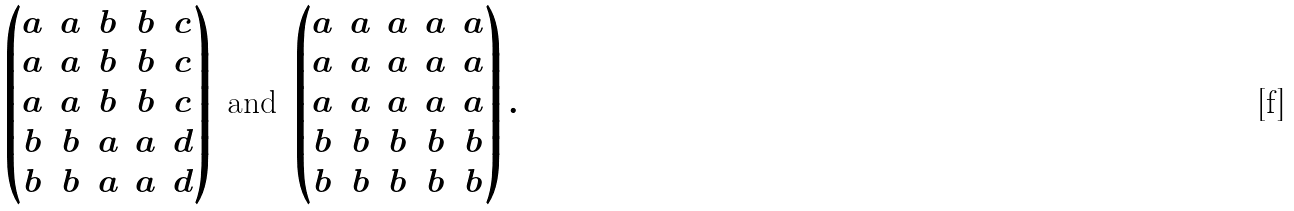Convert formula to latex. <formula><loc_0><loc_0><loc_500><loc_500>\begin{pmatrix} a & a & b & b & c \\ a & a & b & b & c \\ a & a & b & b & c \\ b & b & a & a & d \\ b & b & a & a & d \end{pmatrix} \text { and } \begin{pmatrix} a & a & a & a & a \\ a & a & a & a & a \\ a & a & a & a & a \\ b & b & b & b & b \\ b & b & b & b & b \end{pmatrix} .</formula> 